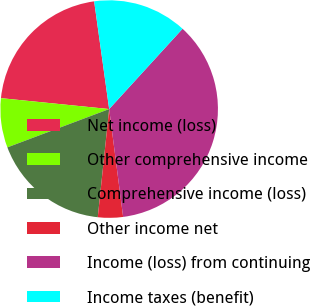Convert chart. <chart><loc_0><loc_0><loc_500><loc_500><pie_chart><fcel>Net income (loss)<fcel>Other comprehensive income<fcel>Comprehensive income (loss)<fcel>Other income net<fcel>Income (loss) from continuing<fcel>Income taxes (benefit)<nl><fcel>21.2%<fcel>7.33%<fcel>17.6%<fcel>3.72%<fcel>36.17%<fcel>13.99%<nl></chart> 